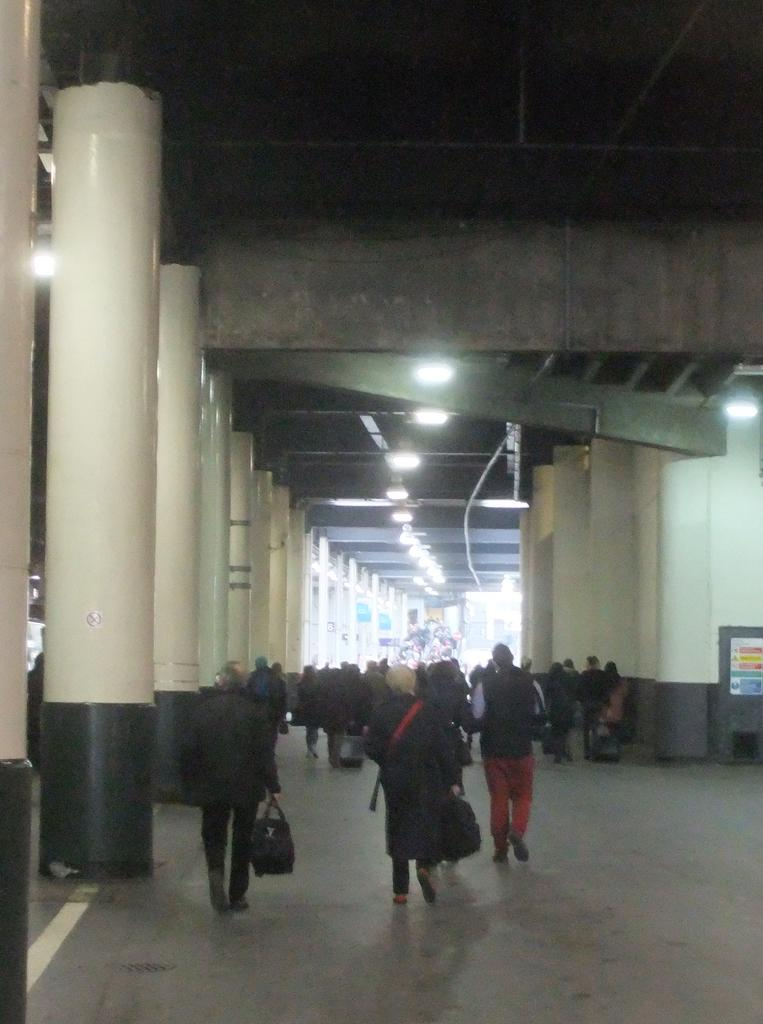What type of structures can be seen in the image? There are pillars in the image. What else can be seen in the image besides the pillars? There are lights, boards, objects, and people in the image. What are some of the people in the image holding? Some people in the image are holding bags. What are the people in the image doing? The people in the image are walking. What type of toy can be seen in the hands of the governor in the image? There is no governor or toy present in the image. 